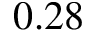<formula> <loc_0><loc_0><loc_500><loc_500>0 . 2 8</formula> 